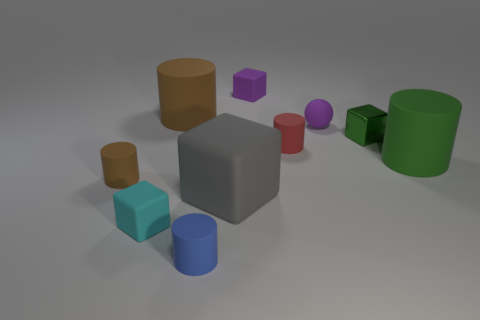What number of big objects are brown things or purple rubber spheres?
Keep it short and to the point. 1. Does the tiny block in front of the green shiny block have the same material as the blue cylinder?
Provide a succinct answer. Yes. What is the shape of the brown thing behind the tiny cylinder on the left side of the big cylinder that is left of the small blue matte cylinder?
Your answer should be very brief. Cylinder. How many brown objects are metallic objects or small matte cylinders?
Offer a terse response. 1. Are there the same number of green matte things that are on the left side of the metallic block and big green cylinders that are to the left of the big brown thing?
Offer a very short reply. Yes. Does the brown matte thing that is right of the tiny brown matte thing have the same shape as the metallic thing that is behind the large green thing?
Provide a succinct answer. No. Is there any other thing that has the same shape as the cyan matte thing?
Give a very brief answer. Yes. What is the shape of the gray thing that is the same material as the large green cylinder?
Give a very brief answer. Cube. Are there the same number of tiny green blocks that are left of the blue matte thing and purple matte balls?
Ensure brevity in your answer.  No. Is the brown thing behind the tiny green object made of the same material as the object in front of the cyan cube?
Offer a terse response. Yes. 